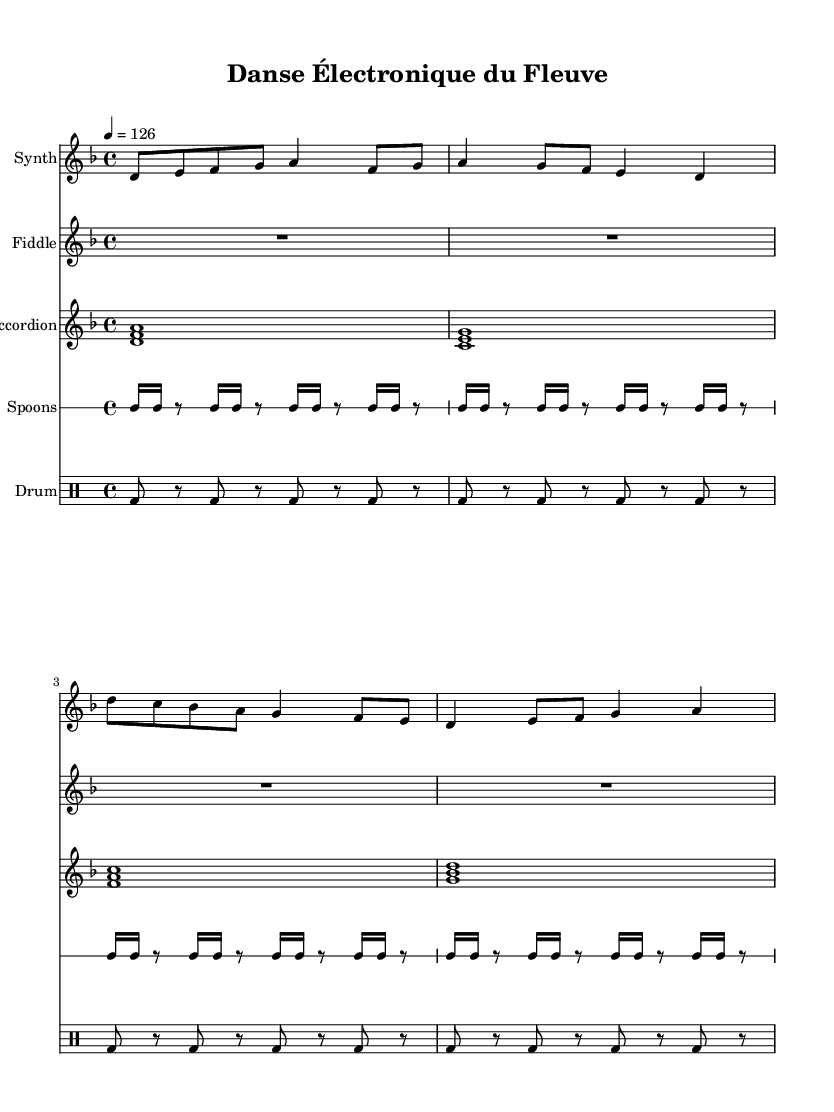What is the key signature of this music? The key signature is indicated by the number of sharps or flats at the beginning of the staff. In this piece, there are no sharps or flats shown, which means it is in D minor, as noted by the key signature symbol.
Answer: D minor What is the time signature of this music? The time signature is shown at the beginning of the music, represented by two numbers. In this case, it is 4 over 4, indicating that there are four beats in each measure and the quarter note receives one beat.
Answer: 4/4 What is the tempo marking of this piece? The tempo marking is indicated at the beginning and tells the performer how fast to play the music. Here, the tempo is marked as 4 equals 126, which indicates that there should be 126 beats per minute.
Answer: 126 How many measures are there in the synthesizer part? To find the number of measures in the synthesizer part, we count the distinct group of beats with bar lines separating them. In the synthesizer part, there are 8 measures, as indicated by the grouping of notes before each bar line.
Answer: 8 What instruments are included in this composition? The instruments are listed at the beginning of each staff and in the score structure. The composition includes a synthesizer, fiddle, accordion, spoons, and a drum machine, as shown explicitly in the music notation.
Answer: Synthesizer, fiddle, accordion, spoons, drum machine What rhythmic pattern is predominantly used by the spoons? The rhythmic pattern used by the spoons is indicated by the sequence of 16th notes followed by rests. Counting through this pattern across the measures shows a repetitive cycle of playing and resting, specifically a four-sixteenth rhythmic pattern.
Answer: Four-sixteenth Which instrument plays a sustained note while others have rhythmic articulation? The fiddle part is indicated with a rest for the full measure and marked with a whole note, suggesting it plays a continuous or sustained tone while the other instruments feature more rhythmic movement in their parts.
Answer: Fiddle 